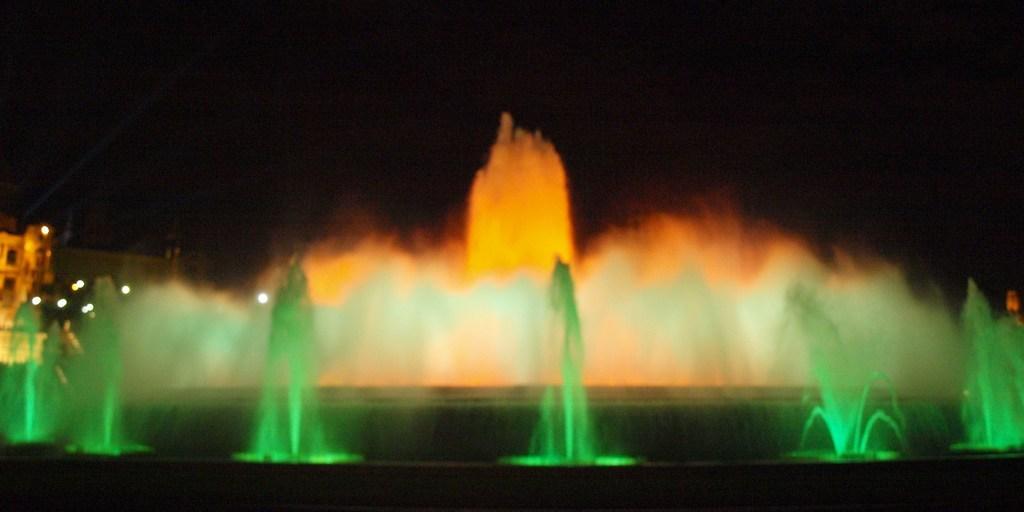Describe this image in one or two sentences. In this picture I can see a fountain with different colors, behind we can see the building. 